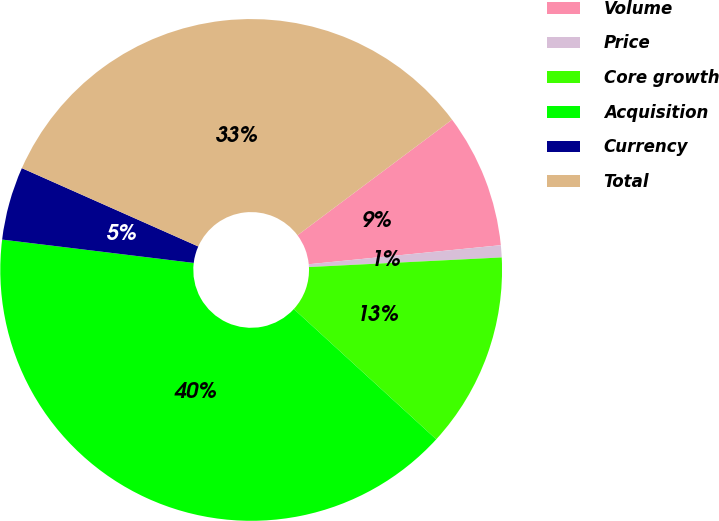Convert chart. <chart><loc_0><loc_0><loc_500><loc_500><pie_chart><fcel>Volume<fcel>Price<fcel>Core growth<fcel>Acquisition<fcel>Currency<fcel>Total<nl><fcel>8.65%<fcel>0.78%<fcel>12.59%<fcel>40.14%<fcel>4.72%<fcel>33.13%<nl></chart> 